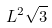<formula> <loc_0><loc_0><loc_500><loc_500>L ^ { 2 } \sqrt { 3 }</formula> 